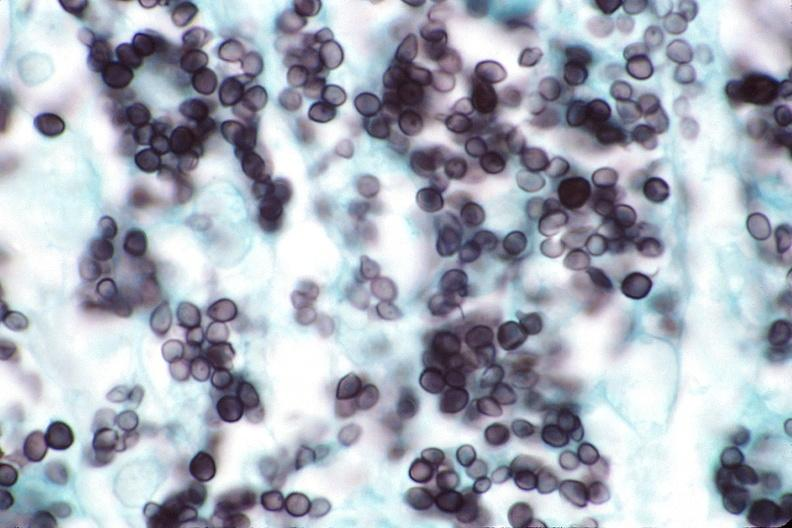s respiratory present?
Answer the question using a single word or phrase. Yes 